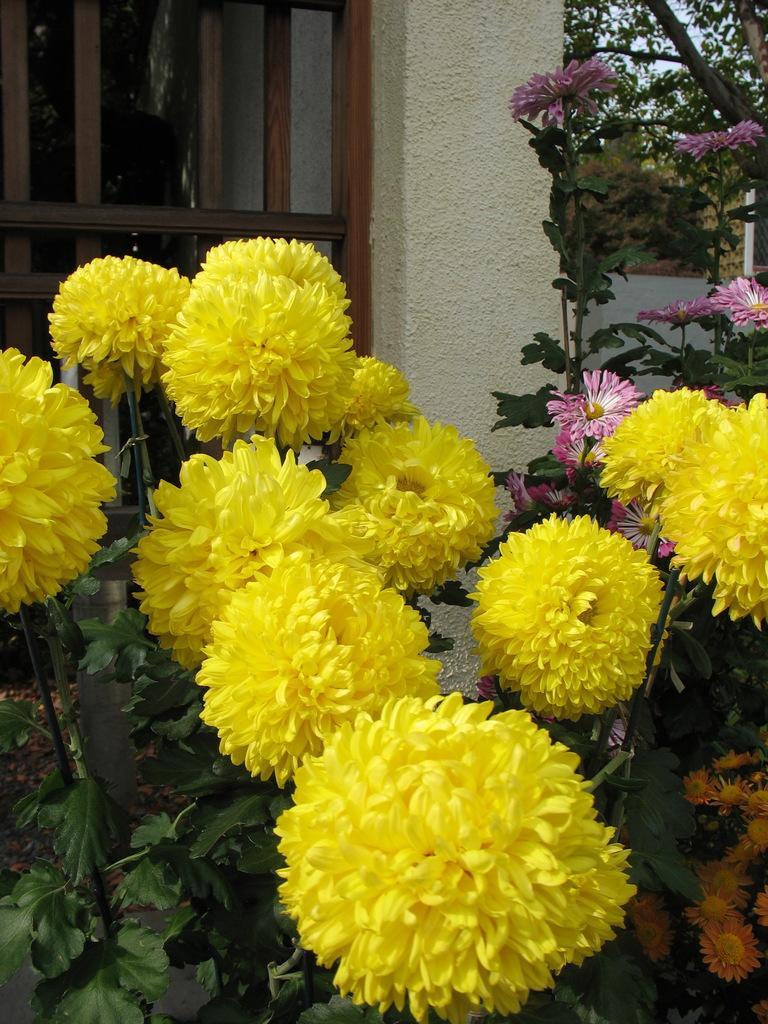Describe this image in one or two sentences. In the image we can see there are flowers on the plant and the flowers are in yellow colour, orange colour and pink colour. Behind there is window on the wall and there are trees. 